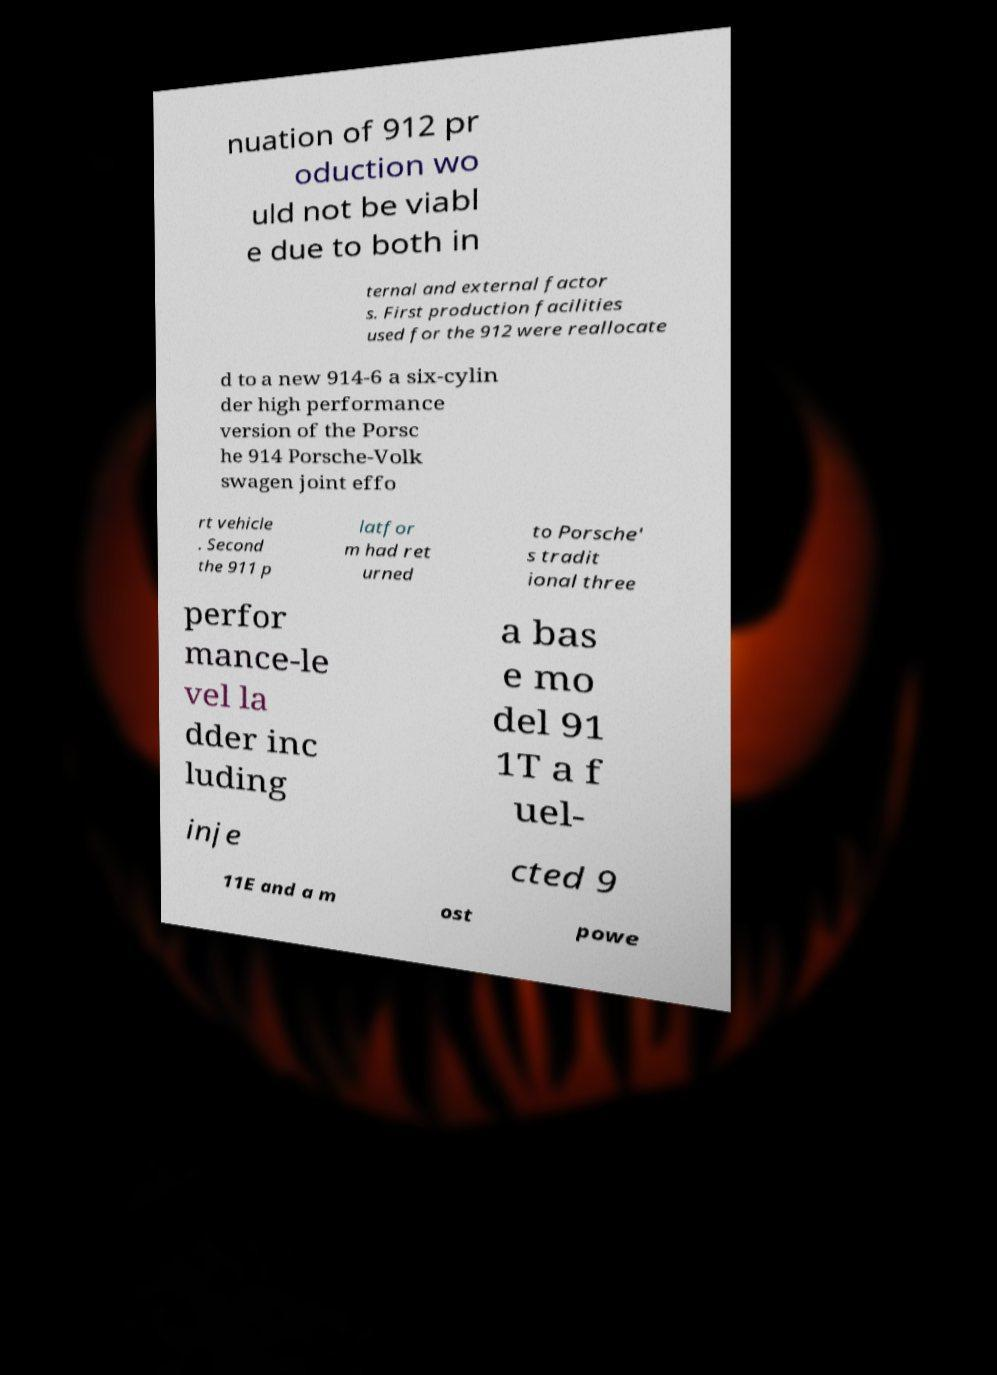Could you extract and type out the text from this image? nuation of 912 pr oduction wo uld not be viabl e due to both in ternal and external factor s. First production facilities used for the 912 were reallocate d to a new 914-6 a six-cylin der high performance version of the Porsc he 914 Porsche-Volk swagen joint effo rt vehicle . Second the 911 p latfor m had ret urned to Porsche' s tradit ional three perfor mance-le vel la dder inc luding a bas e mo del 91 1T a f uel- inje cted 9 11E and a m ost powe 